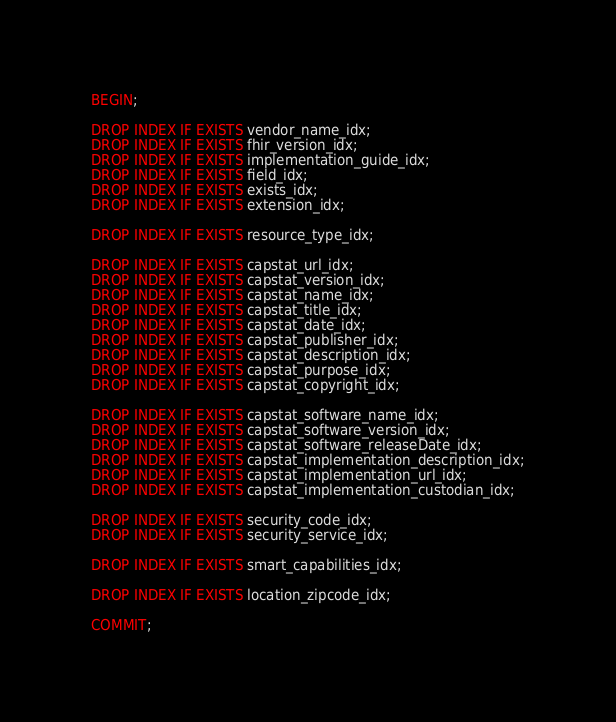<code> <loc_0><loc_0><loc_500><loc_500><_SQL_>BEGIN;

DROP INDEX IF EXISTS vendor_name_idx;
DROP INDEX IF EXISTS fhir_version_idx;
DROP INDEX IF EXISTS implementation_guide_idx;
DROP INDEX IF EXISTS field_idx;
DROP INDEX IF EXISTS exists_idx;
DROP INDEX IF EXISTS extension_idx;

DROP INDEX IF EXISTS resource_type_idx;

DROP INDEX IF EXISTS capstat_url_idx;
DROP INDEX IF EXISTS capstat_version_idx;
DROP INDEX IF EXISTS capstat_name_idx;
DROP INDEX IF EXISTS capstat_title_idx;
DROP INDEX IF EXISTS capstat_date_idx;
DROP INDEX IF EXISTS capstat_publisher_idx;
DROP INDEX IF EXISTS capstat_description_idx;
DROP INDEX IF EXISTS capstat_purpose_idx;
DROP INDEX IF EXISTS capstat_copyright_idx;

DROP INDEX IF EXISTS capstat_software_name_idx;
DROP INDEX IF EXISTS capstat_software_version_idx;
DROP INDEX IF EXISTS capstat_software_releaseDate_idx;
DROP INDEX IF EXISTS capstat_implementation_description_idx;
DROP INDEX IF EXISTS capstat_implementation_url_idx;
DROP INDEX IF EXISTS capstat_implementation_custodian_idx;

DROP INDEX IF EXISTS security_code_idx;
DROP INDEX IF EXISTS security_service_idx;

DROP INDEX IF EXISTS smart_capabilities_idx;

DROP INDEX IF EXISTS location_zipcode_idx;

COMMIT;</code> 